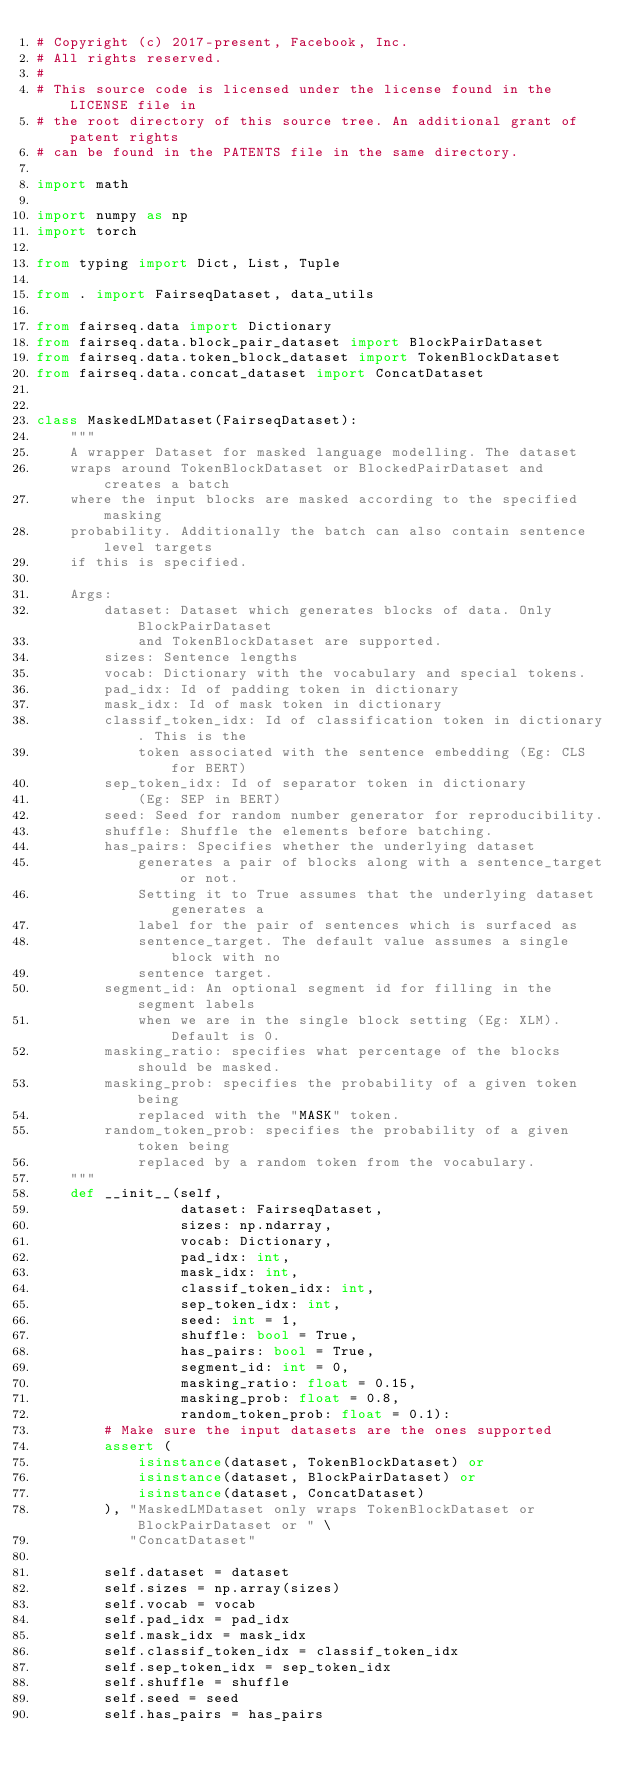<code> <loc_0><loc_0><loc_500><loc_500><_Python_># Copyright (c) 2017-present, Facebook, Inc.
# All rights reserved.
#
# This source code is licensed under the license found in the LICENSE file in
# the root directory of this source tree. An additional grant of patent rights
# can be found in the PATENTS file in the same directory.

import math

import numpy as np
import torch

from typing import Dict, List, Tuple

from . import FairseqDataset, data_utils

from fairseq.data import Dictionary
from fairseq.data.block_pair_dataset import BlockPairDataset
from fairseq.data.token_block_dataset import TokenBlockDataset
from fairseq.data.concat_dataset import ConcatDataset


class MaskedLMDataset(FairseqDataset):
    """
    A wrapper Dataset for masked language modelling. The dataset
    wraps around TokenBlockDataset or BlockedPairDataset and creates a batch
    where the input blocks are masked according to the specified masking
    probability. Additionally the batch can also contain sentence level targets
    if this is specified.

    Args:
        dataset: Dataset which generates blocks of data. Only BlockPairDataset
            and TokenBlockDataset are supported.
        sizes: Sentence lengths
        vocab: Dictionary with the vocabulary and special tokens.
        pad_idx: Id of padding token in dictionary
        mask_idx: Id of mask token in dictionary
        classif_token_idx: Id of classification token in dictionary. This is the
            token associated with the sentence embedding (Eg: CLS for BERT)
        sep_token_idx: Id of separator token in dictionary
            (Eg: SEP in BERT)
        seed: Seed for random number generator for reproducibility.
        shuffle: Shuffle the elements before batching.
        has_pairs: Specifies whether the underlying dataset
            generates a pair of blocks along with a sentence_target or not.
            Setting it to True assumes that the underlying dataset generates a
            label for the pair of sentences which is surfaced as
            sentence_target. The default value assumes a single block with no
            sentence target.
        segment_id: An optional segment id for filling in the segment labels
            when we are in the single block setting (Eg: XLM). Default is 0.
        masking_ratio: specifies what percentage of the blocks should be masked.
        masking_prob: specifies the probability of a given token being
            replaced with the "MASK" token.
        random_token_prob: specifies the probability of a given token being
            replaced by a random token from the vocabulary.
    """
    def __init__(self,
                 dataset: FairseqDataset,
                 sizes: np.ndarray,
                 vocab: Dictionary,
                 pad_idx: int,
                 mask_idx: int,
                 classif_token_idx: int,
                 sep_token_idx: int,
                 seed: int = 1,
                 shuffle: bool = True,
                 has_pairs: bool = True,
                 segment_id: int = 0,
                 masking_ratio: float = 0.15,
                 masking_prob: float = 0.8,
                 random_token_prob: float = 0.1):
        # Make sure the input datasets are the ones supported
        assert (
            isinstance(dataset, TokenBlockDataset) or
            isinstance(dataset, BlockPairDataset) or
            isinstance(dataset, ConcatDataset)
        ), "MaskedLMDataset only wraps TokenBlockDataset or BlockPairDataset or " \
           "ConcatDataset"

        self.dataset = dataset
        self.sizes = np.array(sizes)
        self.vocab = vocab
        self.pad_idx = pad_idx
        self.mask_idx = mask_idx
        self.classif_token_idx = classif_token_idx
        self.sep_token_idx = sep_token_idx
        self.shuffle = shuffle
        self.seed = seed
        self.has_pairs = has_pairs</code> 